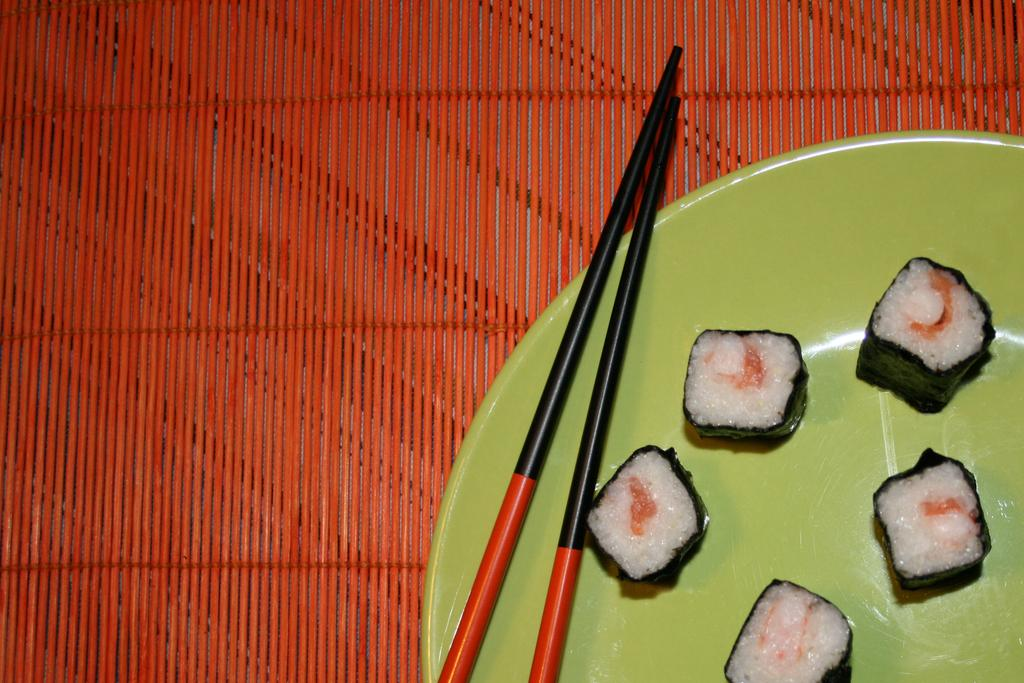What is the main piece of furniture in the image? There is a table in the image. What is placed on the table? A plate and chopsticks are placed on the table. What is on the plate? There is food on the plate. What is the color of the table? The table is red in color. Who is the expert in the frame in the image? There is no frame or expert present in the image. 